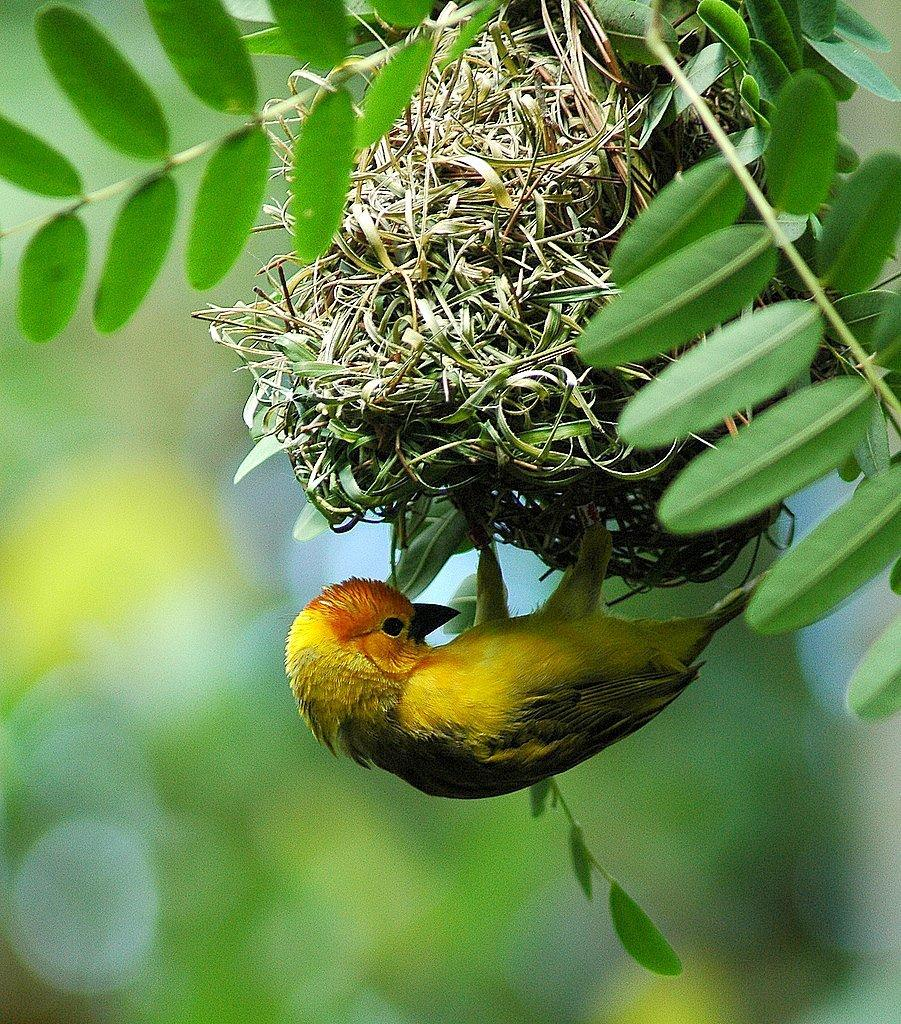What type of natural elements can be seen in the image? There are leaves in the image. What structure is present in the image? There is a nest in the image. What type of animal is in the image? There is a bird in the image. What colors can be observed on the bird? The bird has yellow, black, and orange colors. What type of underwear is the bird wearing in the image? There is no underwear present in the image, and birds do not wear clothing. Can you describe the bun that the bird is sitting on in the image? There is no bun present in the image; the bird is sitting in a nest. 